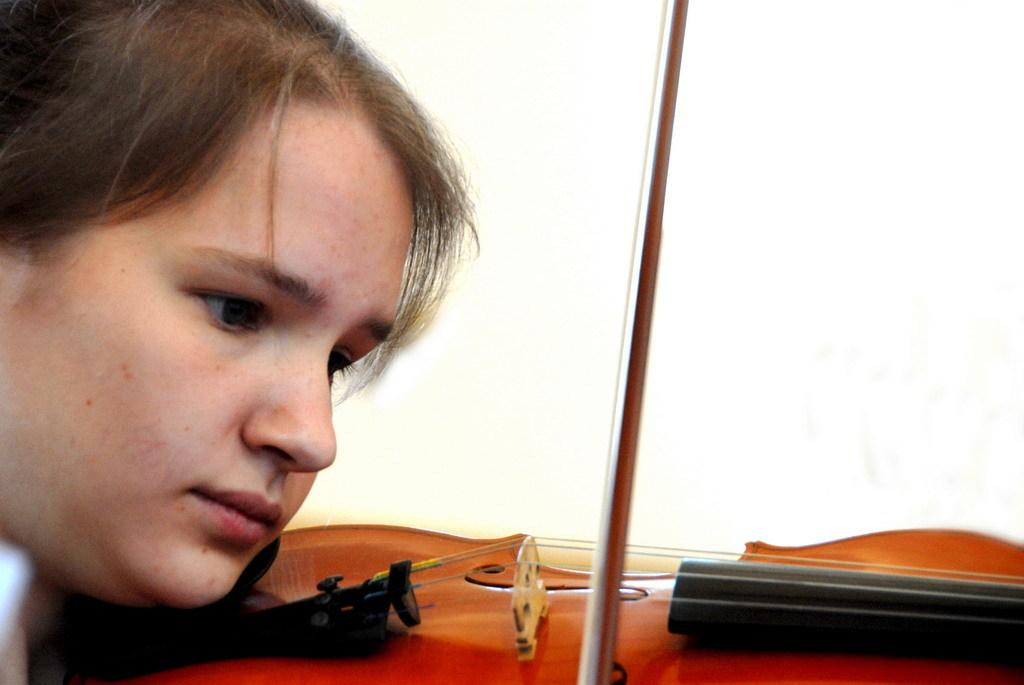What is the main subject of the image? There is a woman in the image. What is the woman doing in the image? The woman is playing the violin. What color is the background of the image? The background of the image is white. What type of clouds can be seen in the image? There are no clouds visible in the image, as the background is white. 